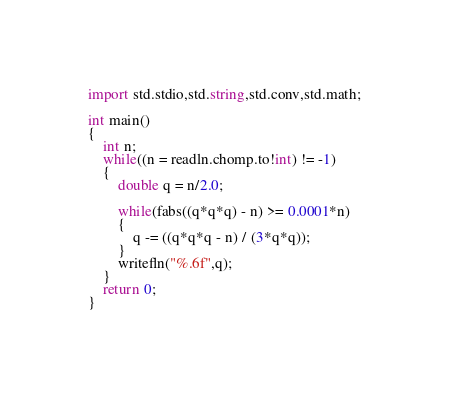Convert code to text. <code><loc_0><loc_0><loc_500><loc_500><_D_>import std.stdio,std.string,std.conv,std.math;

int main()
{
	int n;
	while((n = readln.chomp.to!int) != -1)
	{
		double q = n/2.0;

		while(fabs((q*q*q) - n) >= 0.0001*n)
		{
			q -= ((q*q*q - n) / (3*q*q));
		}
		writefln("%.6f",q);
	}
	return 0;
}</code> 